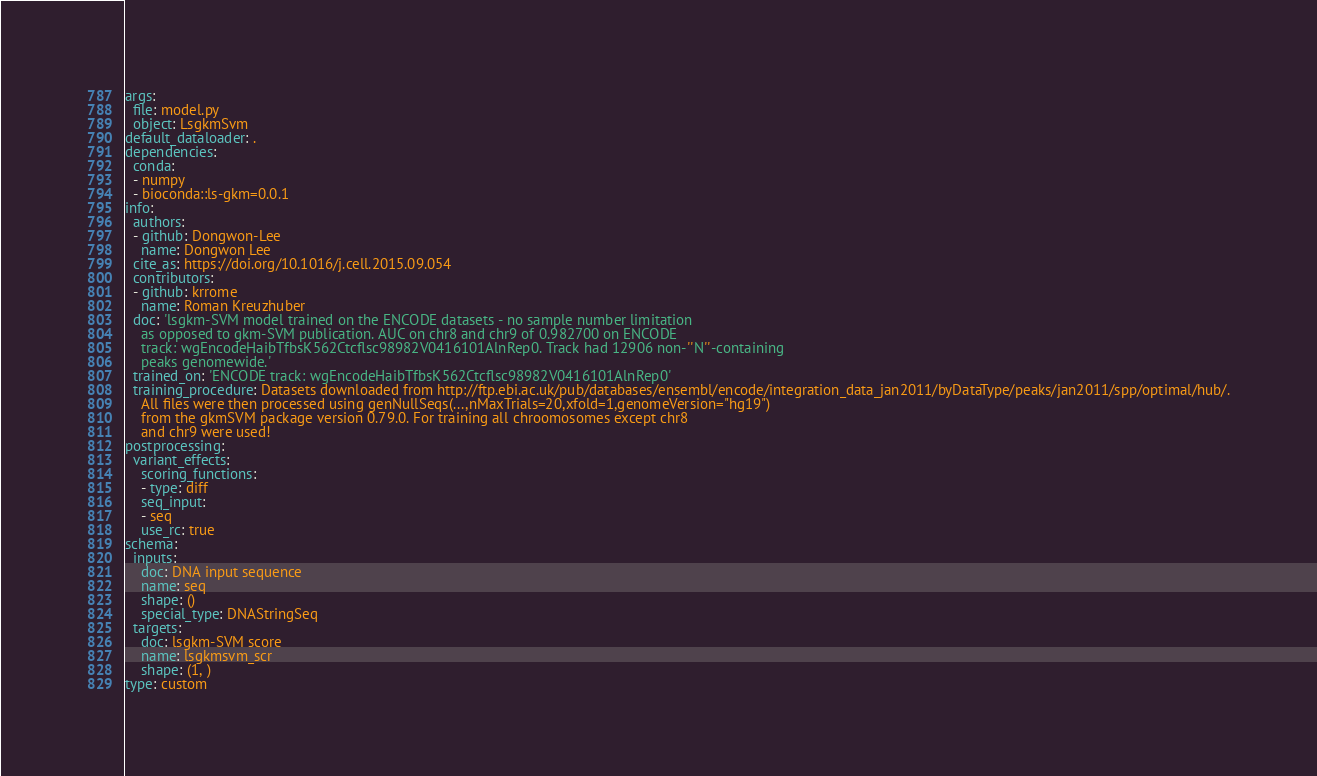Convert code to text. <code><loc_0><loc_0><loc_500><loc_500><_YAML_>args:
  file: model.py
  object: LsgkmSvm
default_dataloader: .
dependencies:
  conda:
  - numpy
  - bioconda::ls-gkm=0.0.1
info:
  authors:
  - github: Dongwon-Lee
    name: Dongwon Lee
  cite_as: https://doi.org/10.1016/j.cell.2015.09.054
  contributors:
  - github: krrome
    name: Roman Kreuzhuber
  doc: 'lsgkm-SVM model trained on the ENCODE datasets - no sample number limitation
    as opposed to gkm-SVM publication. AUC on chr8 and chr9 of 0.982700 on ENCODE
    track: wgEncodeHaibTfbsK562Ctcflsc98982V0416101AlnRep0. Track had 12906 non-''N''-containing
    peaks genomewide.'
  trained_on: 'ENCODE track: wgEncodeHaibTfbsK562Ctcflsc98982V0416101AlnRep0'
  training_procedure: Datasets downloaded from http://ftp.ebi.ac.uk/pub/databases/ensembl/encode/integration_data_jan2011/byDataType/peaks/jan2011/spp/optimal/hub/.
    All files were then processed using genNullSeqs(...,nMaxTrials=20,xfold=1,genomeVersion="hg19")
    from the gkmSVM package version 0.79.0. For training all chroomosomes except chr8
    and chr9 were used!
postprocessing:
  variant_effects:
    scoring_functions:
    - type: diff
    seq_input:
    - seq
    use_rc: true
schema:
  inputs:
    doc: DNA input sequence
    name: seq
    shape: ()
    special_type: DNAStringSeq
  targets:
    doc: lsgkm-SVM score
    name: lsgkmsvm_scr
    shape: (1, )
type: custom
</code> 